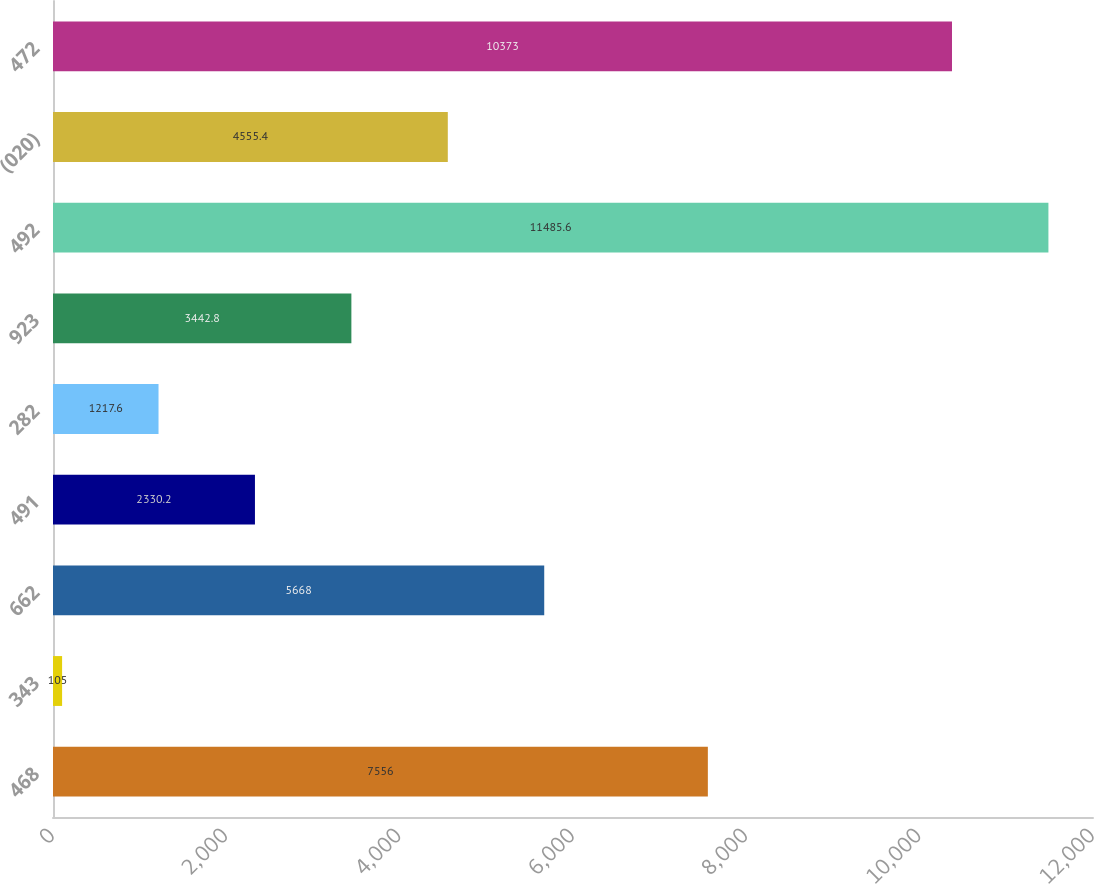Convert chart to OTSL. <chart><loc_0><loc_0><loc_500><loc_500><bar_chart><fcel>468<fcel>343<fcel>662<fcel>491<fcel>282<fcel>923<fcel>492<fcel>(020)<fcel>472<nl><fcel>7556<fcel>105<fcel>5668<fcel>2330.2<fcel>1217.6<fcel>3442.8<fcel>11485.6<fcel>4555.4<fcel>10373<nl></chart> 